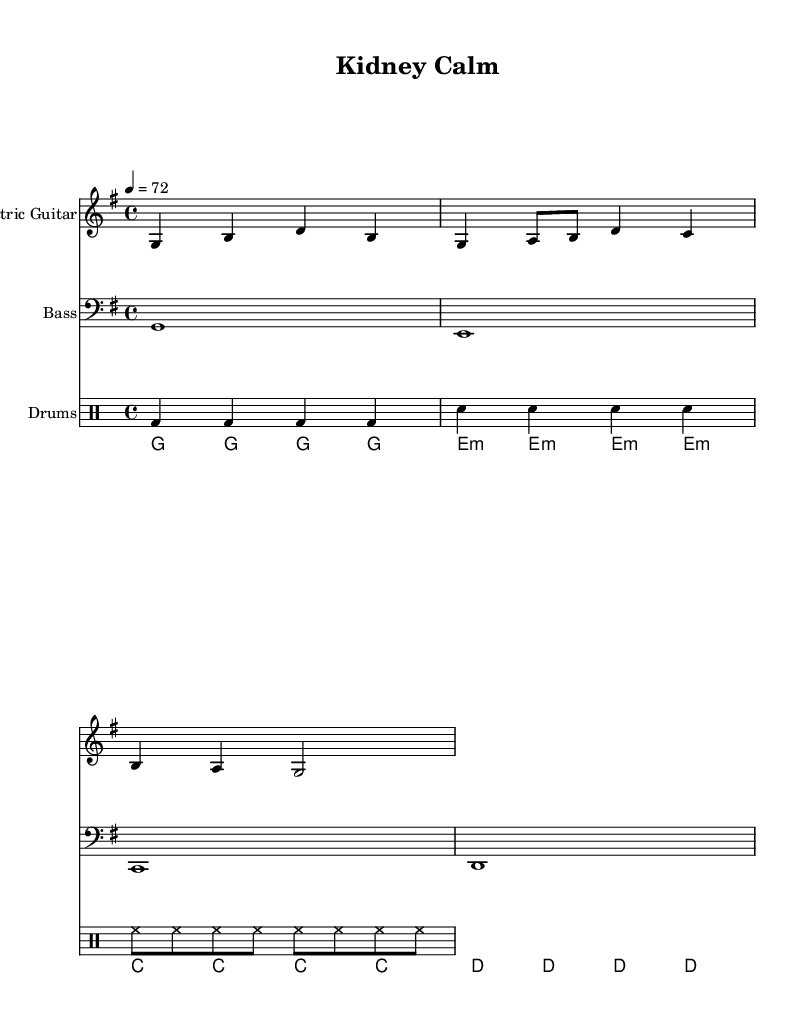what is the key signature of this music? The key signature is G major, which has one sharp (F#). This can be identified by looking at the key signature at the beginning of the staff where the sharp is placed on the F line.
Answer: G major what is the time signature of this music? The time signature is 4/4, which is indicated at the beginning of the piece. This signifies that there are four beats in each measure and the quarter note receives one beat.
Answer: 4/4 what is the tempo marking of this piece? The tempo marking is 72 beats per minute, as indicated above the staff with the "4 = 72" notation. This tells us the speed at which the piece should be played.
Answer: 72 how many measures does the Electric Guitar part contain? The Electric Guitar part contains four measures. This can be counted by identifying the vertical bar lines separating the measures in the part.
Answer: 4 what type of rhythm is predominantly used in the drum part? The predominant rhythm used in the drum part is steady quarter notes for bass drum and snare drum, with eighth notes for hi-hat. This is evident from the consistent note grouping shown in the drum part.
Answer: Steady rhythm which instruments are included in this piece? The instruments included in this piece are Electric Guitar, Bass, Drums, and Keyboard. This can be determined by looking at the labels above each staff that specify the instrument being played.
Answer: Electric Guitar, Bass, Drums, Keyboard what is the overall mood suggested by the music? The overall mood suggested by the music is relaxed and calming, typical of reggae instrumentals, which is often characterized by a laid-back feeling. This can be inferred from the slow tempo and melodic patterns.
Answer: Relaxed 